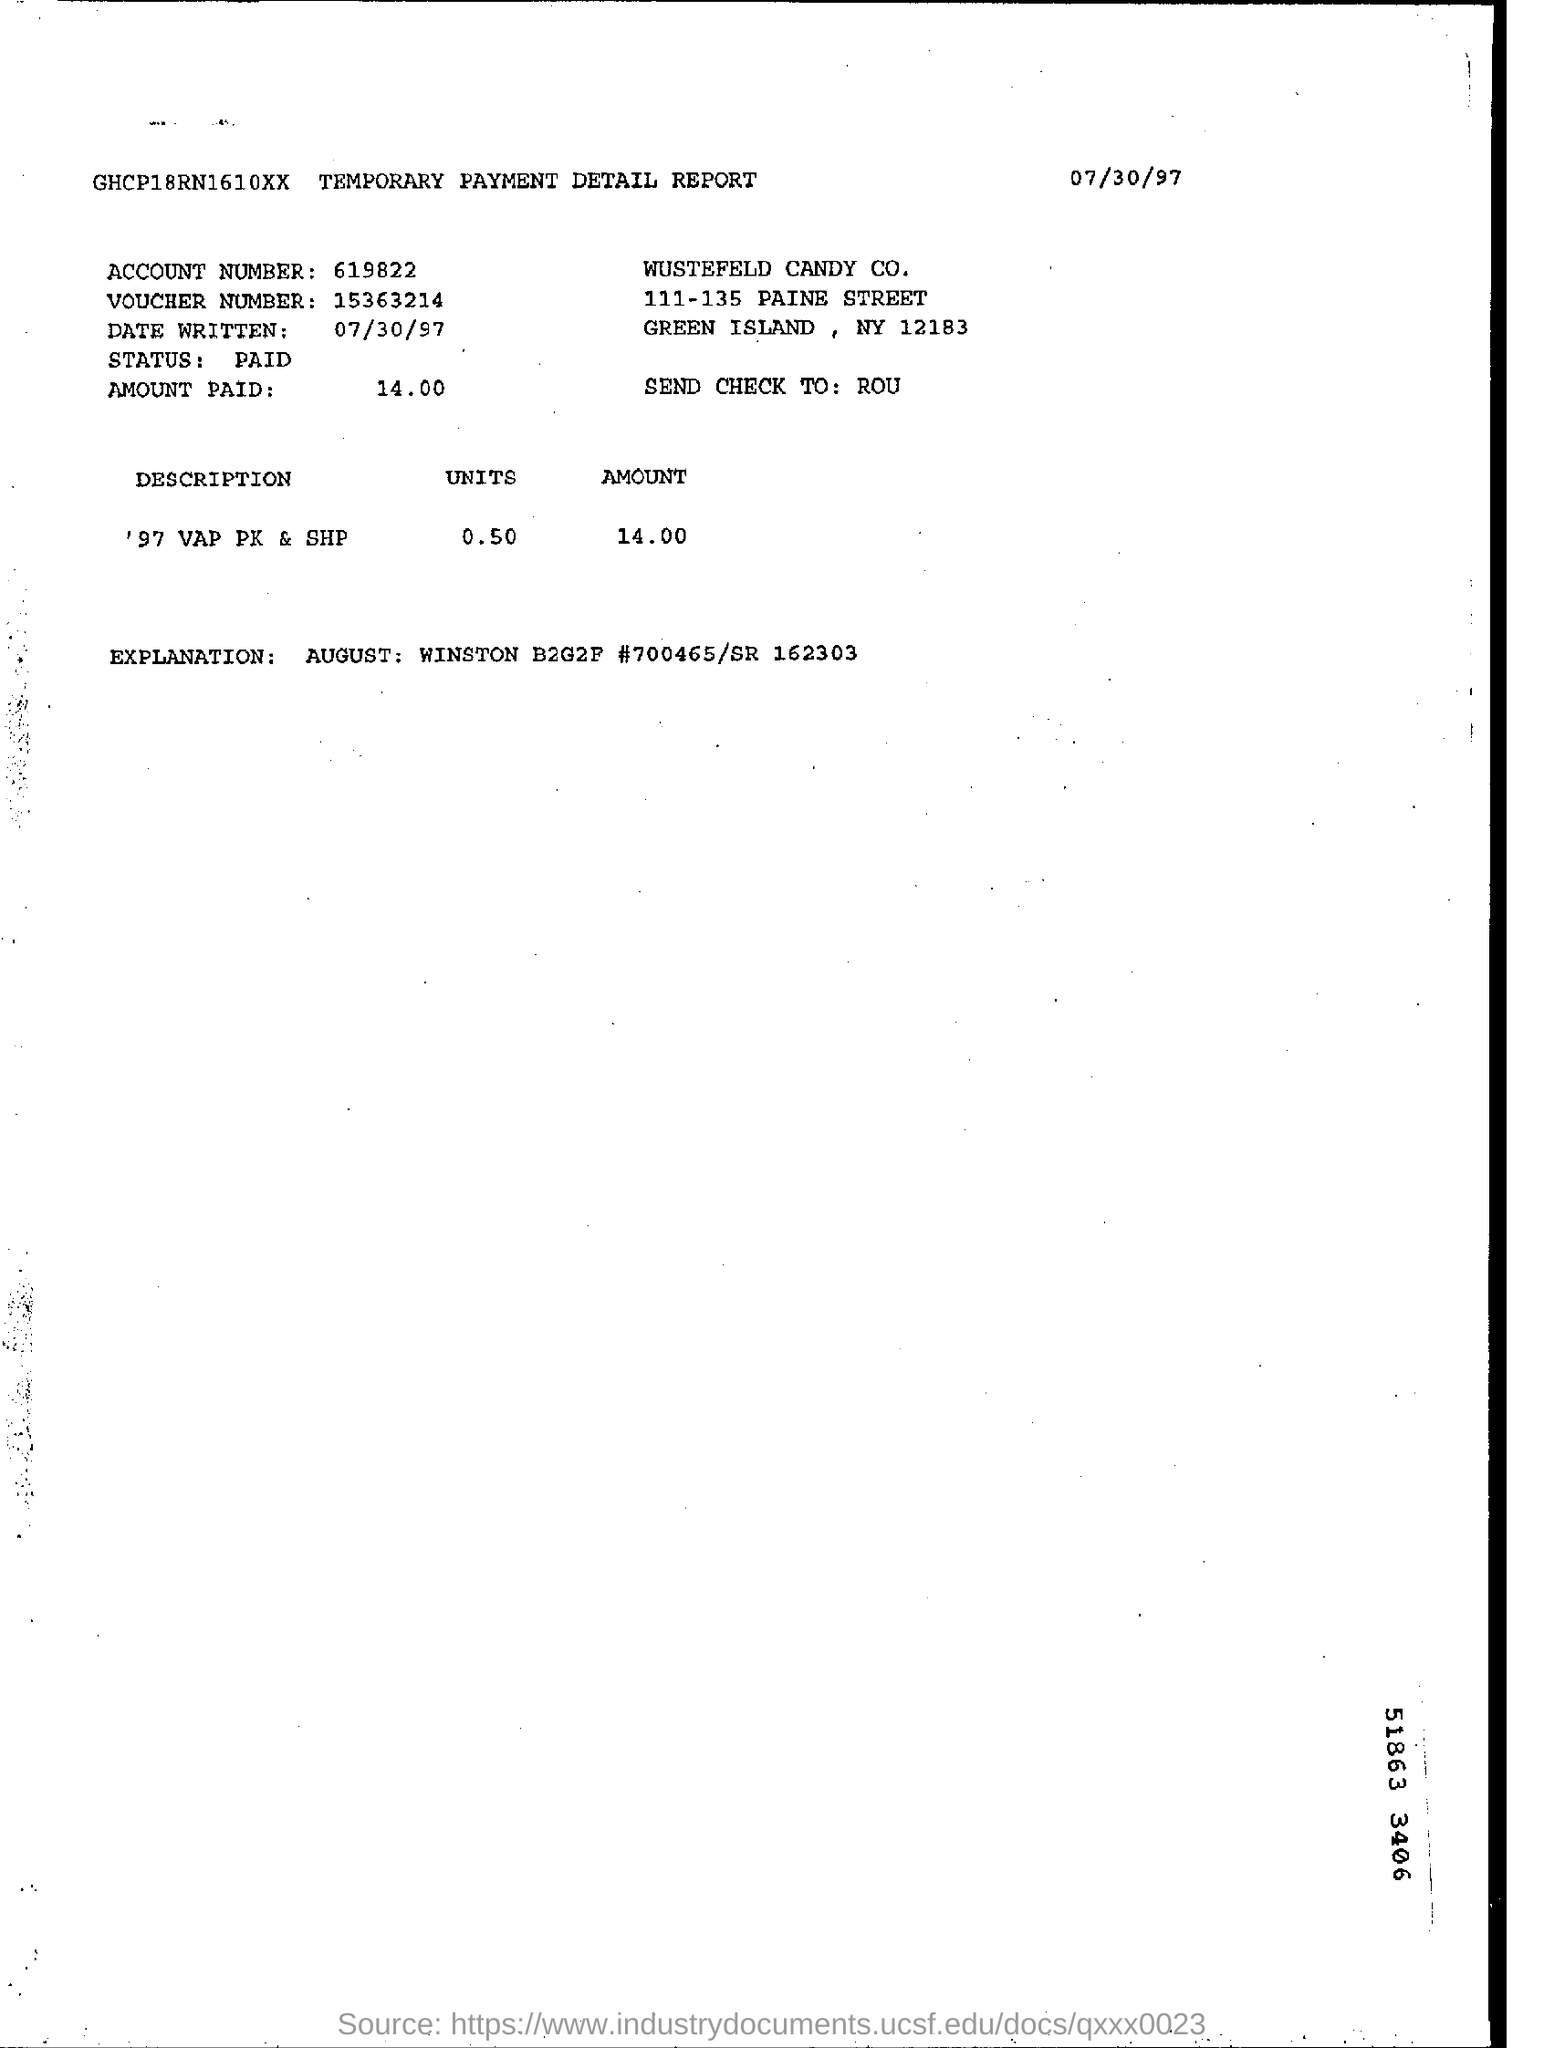Mention a couple of crucial points in this snapshot. The date written on the TEMPORARY PAYMENT DETAIL REPORT is July 30, 1997. The status of the TEMPORARY PAYMENT DETAIL REPORT is PAID. 